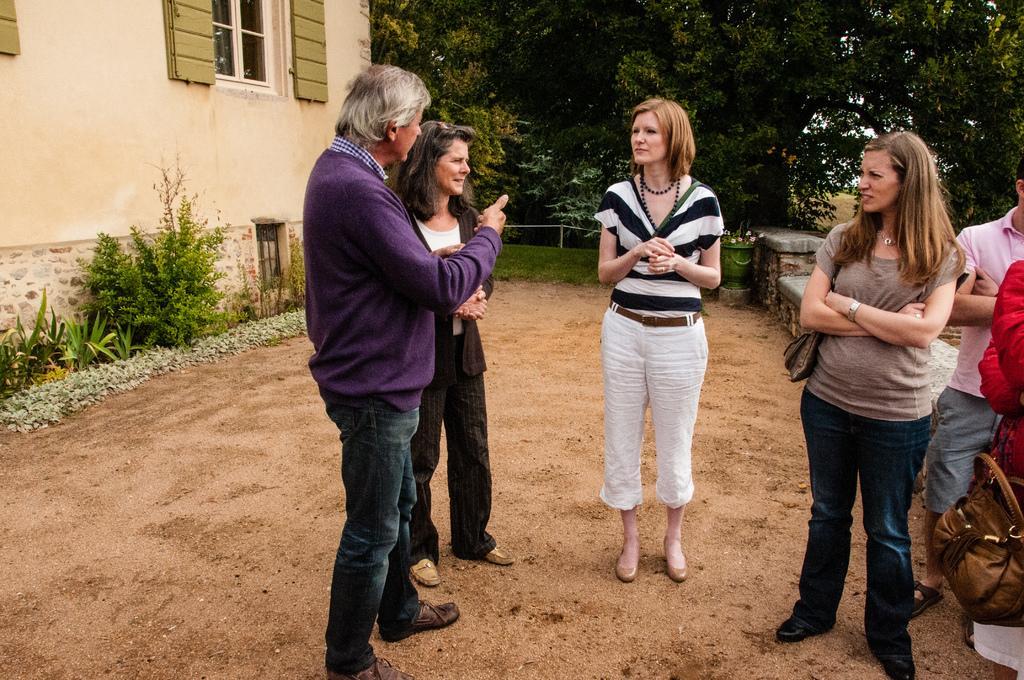Please provide a concise description of this image. This image consists of six persons. At the bottom, there is ground. On the left, we can see small plants and a building along with windows. In the background, there are many trees. On the right, we can see a person wearing a bag. 